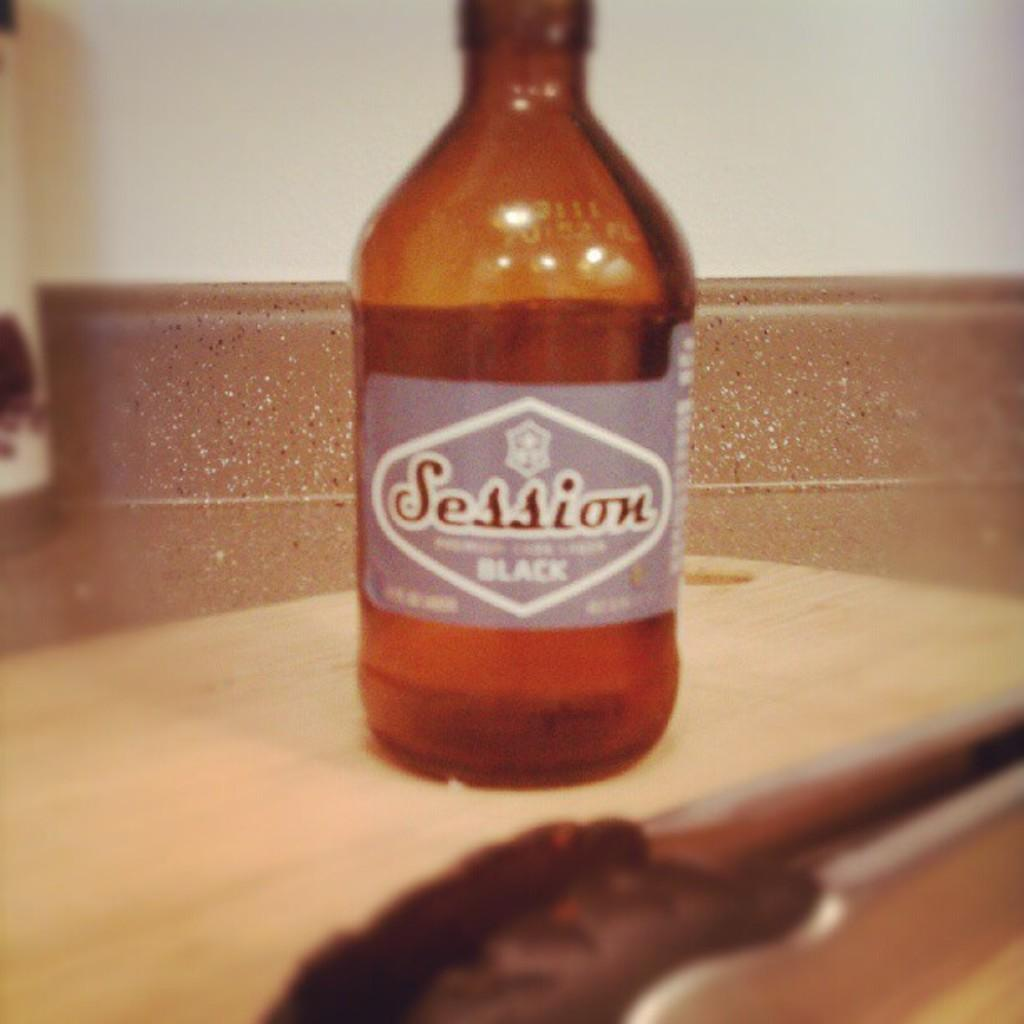What is the main subject in the image? There is an object in the image. Can you describe the object on the table? There is a bottle on a table in the image. What can be seen in the distance in the image? There is a wall in the background of the image. How many passengers are visible in the image? There are no passengers present in the image. What type of lamp is on the table next to the bottle? There is no lamp present in the image; only a bottle is visible on the table. 